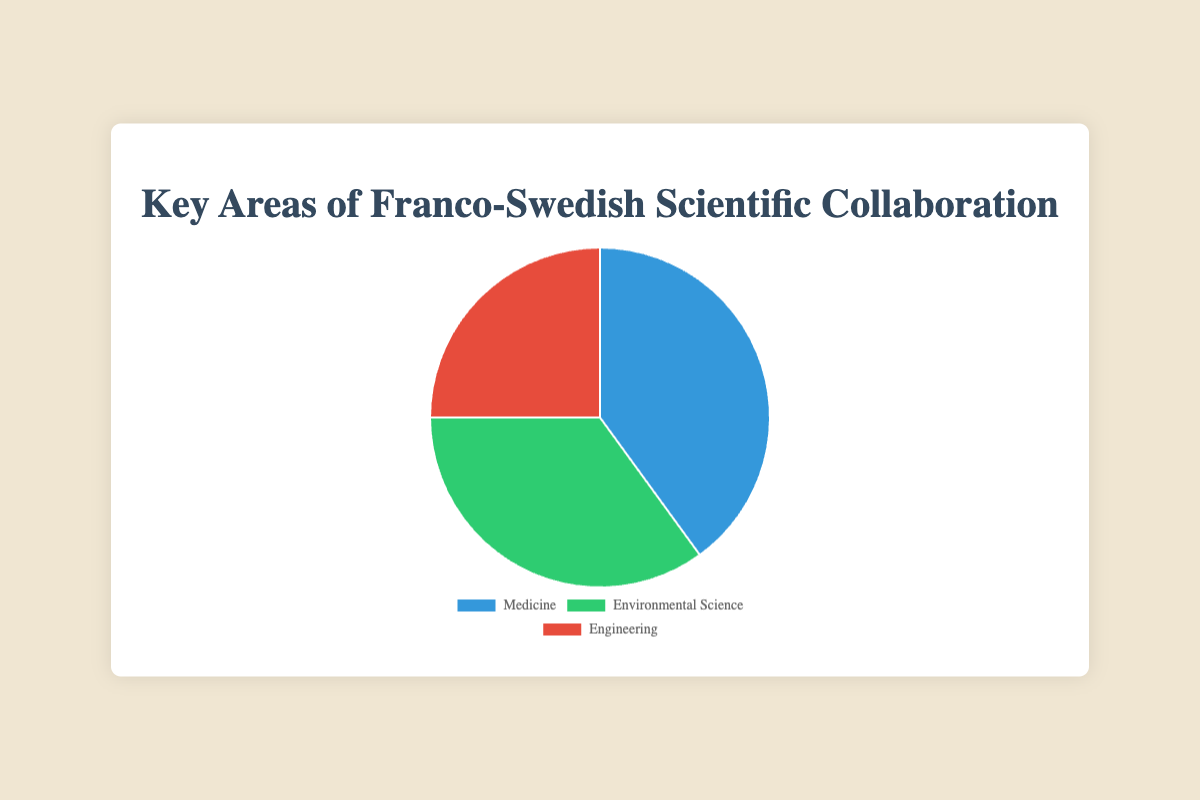What percentage of projects are in the field of Medicine? The pie chart represents the percentage distribution of the key areas of Franco-Swedish scientific collaboration. By looking at the chart, we can see that the area marked "Medicine" occupies 40% of the pie.
Answer: 40% Which scientific area has the least number of projects? The pie chart shows three areas: Medicine, Environmental Science, and Engineering. By observing the size of the slices, we see Engineering has the smallest slice.
Answer: Engineering If we were to combine the percentages for Environmental Science and Engineering, what would be the combined percentage? According to the pie chart, Environmental Science is 35% and Engineering is 25%. Adding these together gives 35% + 25% = 60%.
Answer: 60% What is the difference in percentage points between the areas of Medicine and Engineering? From the pie chart, Medicine accounts for 40% while Engineering accounts for 25%. The difference between these two percentages is 40% - 25% = 15%.
Answer: 15% Which collaboration area is represented by the green color in the pie chart? By looking at the colors in the pie chart, we observe that the green slice represents Environmental Science.
Answer: Environmental Science How does the percentage of Environmental Science projects compare to the percentage of Engineering projects? According to the pie chart, Environmental Science projects constitute 35% and Engineering projects constitute 25%. Environmental Science has a greater percentage by 10%.
Answer: Environmental Science has 10% more What is the average percentage of the three scientific collaboration areas? We have three percentages: Medicine (40%), Environmental Science (35%), and Engineering (25%). To calculate the average: (40 + 35 + 25) / 3 = 33.33%.
Answer: 33.33% Which area has the largest number of collaborative projects, and what is that percentage? The pie chart shows that Medicine has the largest slice, indicating the highest percentage of collaborative projects, which is 40%.
Answer: Medicine, 40% How much more percentage does Medicine have compared to Environmental Science? Medicine is at 40% while Environmental Science is at 35%. The difference is 40% - 35% = 5%.
Answer: 5% Is Medicine collaboration more prevalent than the combined percentages of Engineering and Environmental Science? Medicine's share is 40%. The combined percentage of Engineering and Environmental Science is 25% + 35% = 60%. Medicine has a smaller percentage than the combined share of Environmental Science and Engineering.
Answer: No 